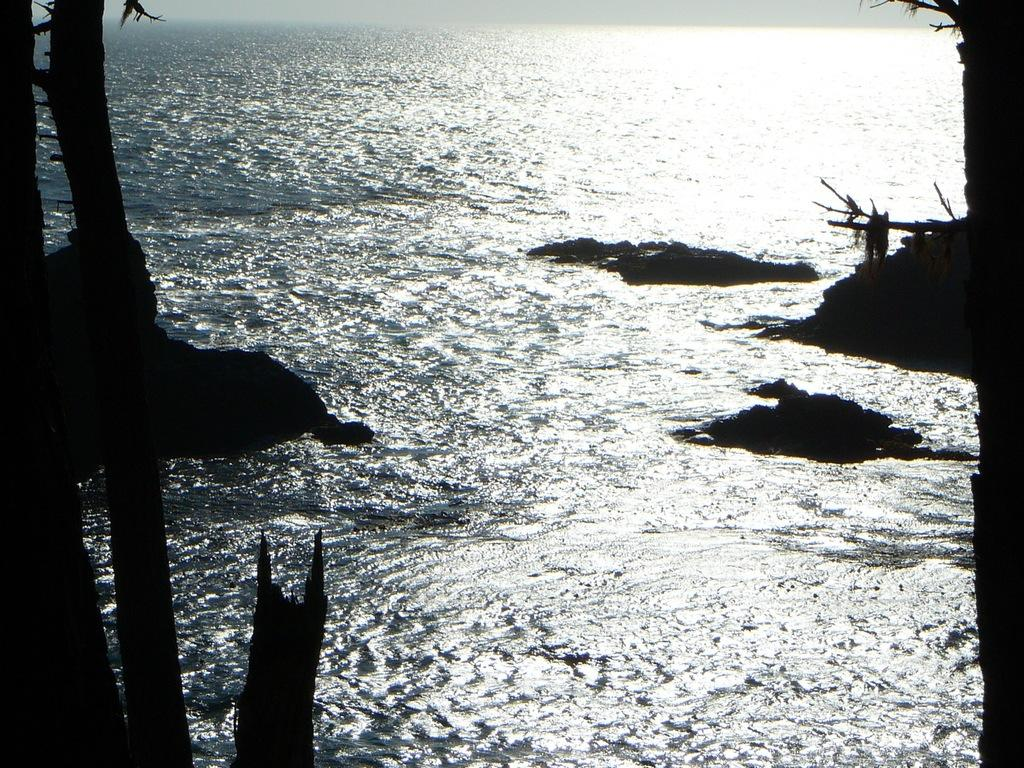What is visible at the bottom of the image? There is water visible at the bottom of the image. What can be found in the water? There are stones in the water. What type of vegetation is near the water? There are trees near the water. Where is the nest located in the image? There is no nest present in the image. What type of cabbage can be seen growing near the water? There is no cabbage present in the image. 